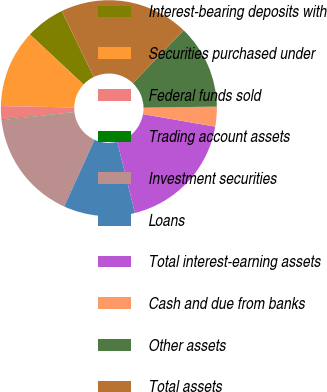<chart> <loc_0><loc_0><loc_500><loc_500><pie_chart><fcel>Interest-bearing deposits with<fcel>Securities purchased under<fcel>Federal funds sold<fcel>Trading account assets<fcel>Investment securities<fcel>Loans<fcel>Total interest-earning assets<fcel>Cash and due from banks<fcel>Other assets<fcel>Total assets<nl><fcel>5.86%<fcel>11.64%<fcel>2.0%<fcel>0.08%<fcel>16.46%<fcel>10.67%<fcel>18.38%<fcel>2.97%<fcel>12.6%<fcel>19.35%<nl></chart> 